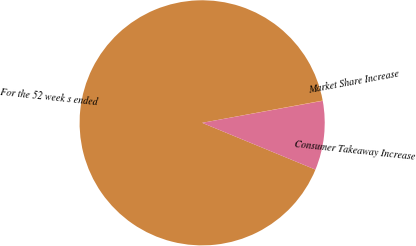Convert chart. <chart><loc_0><loc_0><loc_500><loc_500><pie_chart><fcel>For the 52 week s ended<fcel>Consumer Takeaway Increase<fcel>Market Share Increase<nl><fcel>90.86%<fcel>9.11%<fcel>0.03%<nl></chart> 